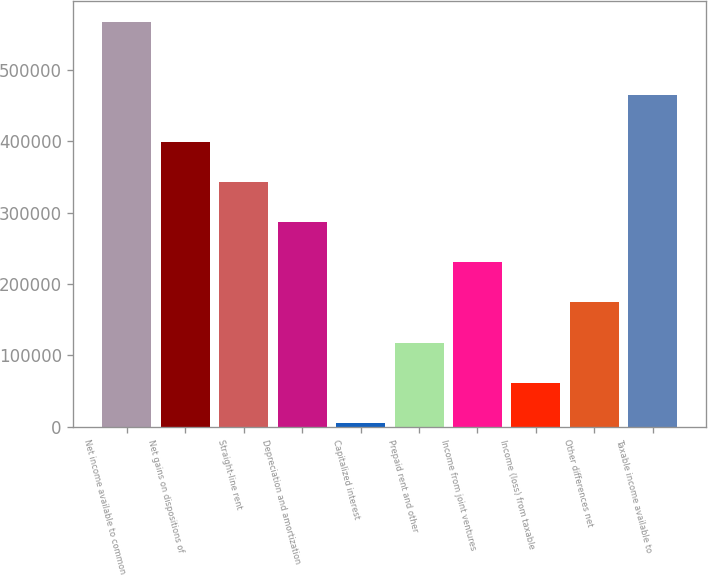Convert chart to OTSL. <chart><loc_0><loc_0><loc_500><loc_500><bar_chart><fcel>Net income available to common<fcel>Net gains on dispositions of<fcel>Straight-line rent<fcel>Depreciation and amortization<fcel>Capitalized interest<fcel>Prepaid rent and other<fcel>Income from joint ventures<fcel>Income (loss) from taxable<fcel>Other differences net<fcel>Taxable income available to<nl><fcel>567885<fcel>399152<fcel>342908<fcel>286664<fcel>5443<fcel>117931<fcel>230420<fcel>61687.2<fcel>174176<fcel>465509<nl></chart> 